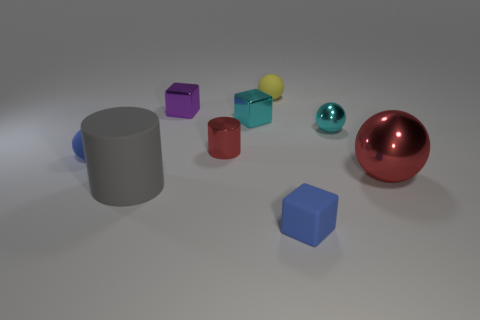Can you describe the arrangement of objects on the surface? Sure, the objects are spread out across the surface seemingly at random. There's a large gray cylinder to the left, with various shapes like cubes and spheres to its right, in an assortment of colors including purple, red, yellow, teal, and shiny red. 